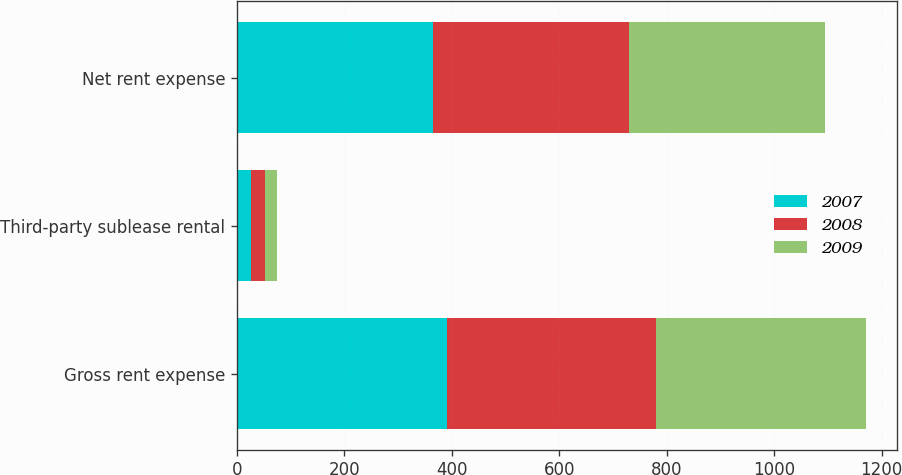Convert chart. <chart><loc_0><loc_0><loc_500><loc_500><stacked_bar_chart><ecel><fcel>Gross rent expense<fcel>Third-party sublease rental<fcel>Net rent expense<nl><fcel>2007<fcel>391.5<fcel>26.8<fcel>364.7<nl><fcel>2008<fcel>389.4<fcel>24.9<fcel>364.5<nl><fcel>2009<fcel>389.9<fcel>23.5<fcel>366.4<nl></chart> 